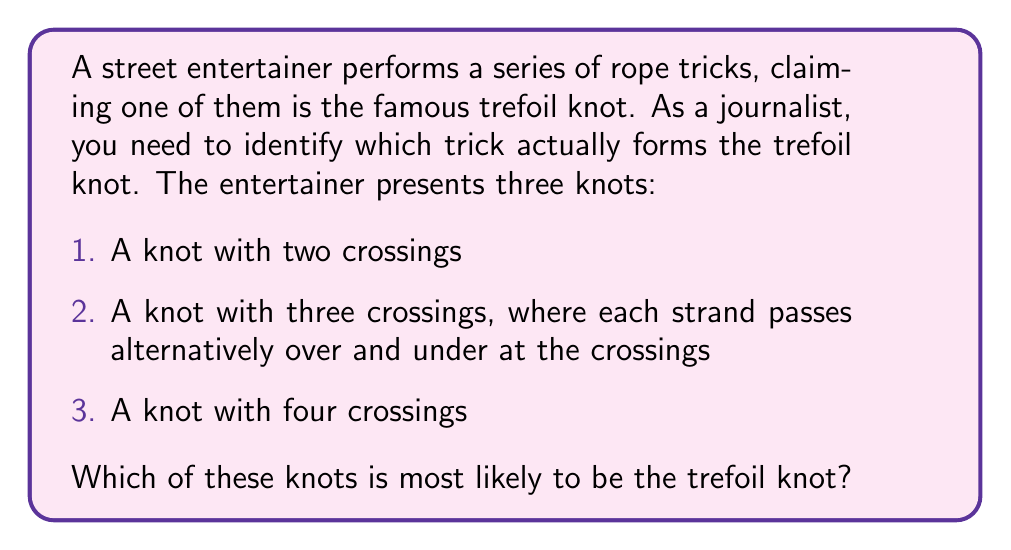Provide a solution to this math problem. To identify the trefoil knot, we need to understand its properties:

1. The trefoil knot is the simplest non-trivial knot in knot theory.

2. It has a crossing number of 3, meaning it has the minimum number of crossings required to form a non-trivial knot.

3. The trefoil knot can be represented mathematically as the $(2,3)$-torus knot, denoted as $T(2,3)$.

4. Its Jones polynomial is:

   $$V(t) = t + t^3 - t^4$$

Now, let's analyze each knot presented by the street entertainer:

1. A knot with two crossings: This cannot be the trefoil knot as it has fewer crossings than required. It is likely the unknot (trivial knot).

2. A knot with three crossings, where each strand passes alternatively over and under at the crossings: This description matches the trefoil knot perfectly. The alternating over-under pattern at three crossings is a key characteristic of the trefoil knot.

3. A knot with four crossings: This knot has more crossings than the trefoil knot. It could be a more complex knot, such as the figure-eight knot.

Therefore, the knot most likely to be the trefoil knot is the second one, with three crossings and an alternating over-under pattern.
Answer: Knot 2 (three crossings, alternating over-under) 